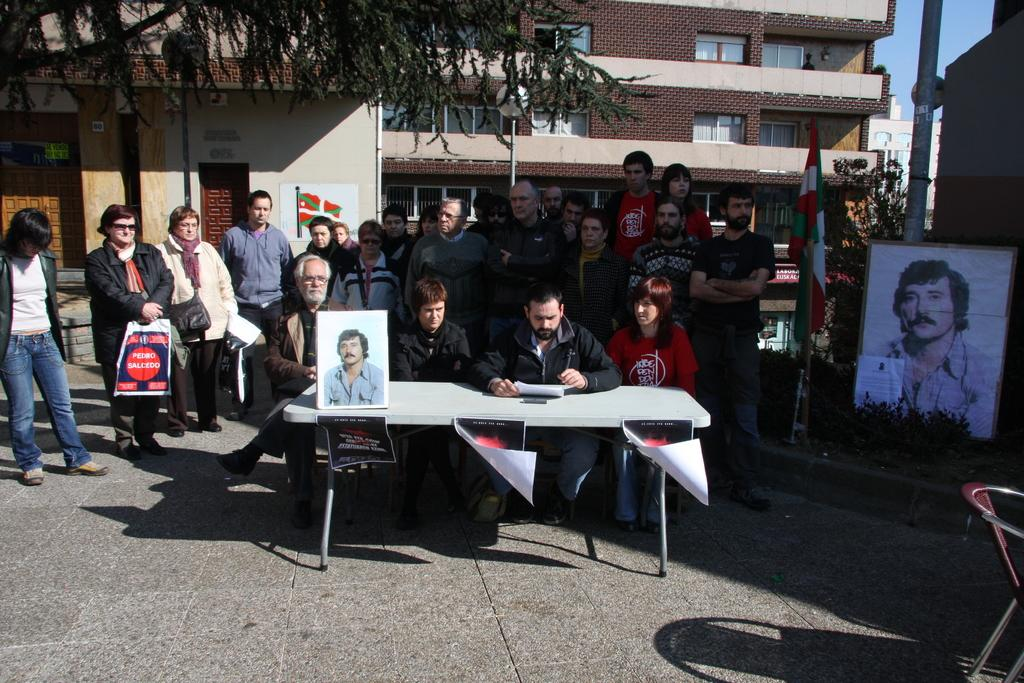What are the people in the image doing? There are people standing on a road and sitting in front of tables. What can be seen in the background of the image? There is a building and a tree visible in the background. What news is being broadcasted from the tree in the image? There is no news being broadcasted from the tree in the image, as trees do not have the ability to broadcast news. 